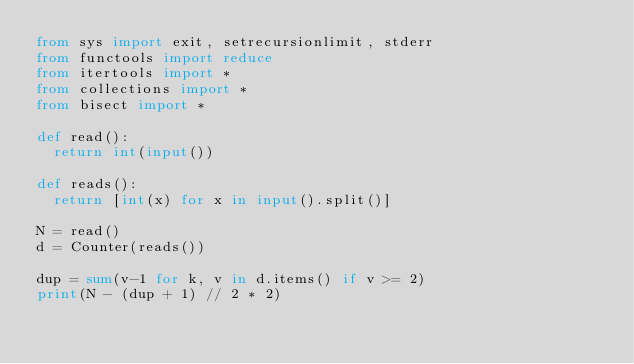Convert code to text. <code><loc_0><loc_0><loc_500><loc_500><_Python_>from sys import exit, setrecursionlimit, stderr
from functools import reduce
from itertools import *
from collections import *
from bisect import *

def read():
  return int(input())
 
def reads():
  return [int(x) for x in input().split()]

N = read()
d = Counter(reads())

dup = sum(v-1 for k, v in d.items() if v >= 2)
print(N - (dup + 1) // 2 * 2)
</code> 